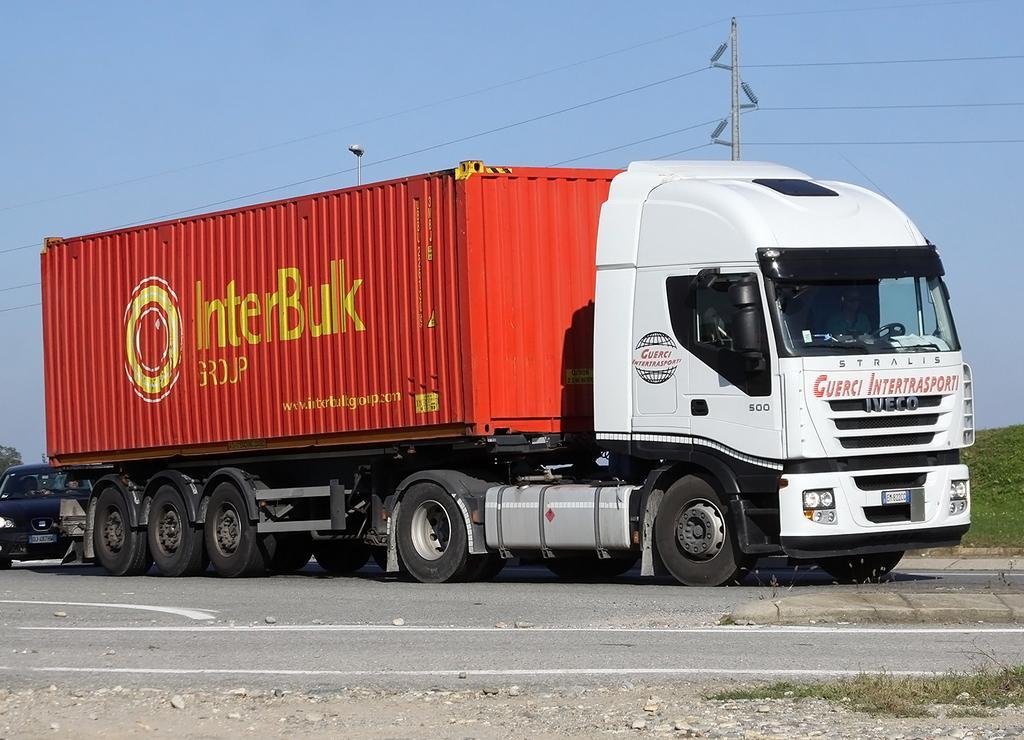Could you give a brief overview of what you see in this image? In this image, we can see some vehicles. We can see the ground. We can see some stones and some grass. There are a few poles and wires. We can also see the sky. 